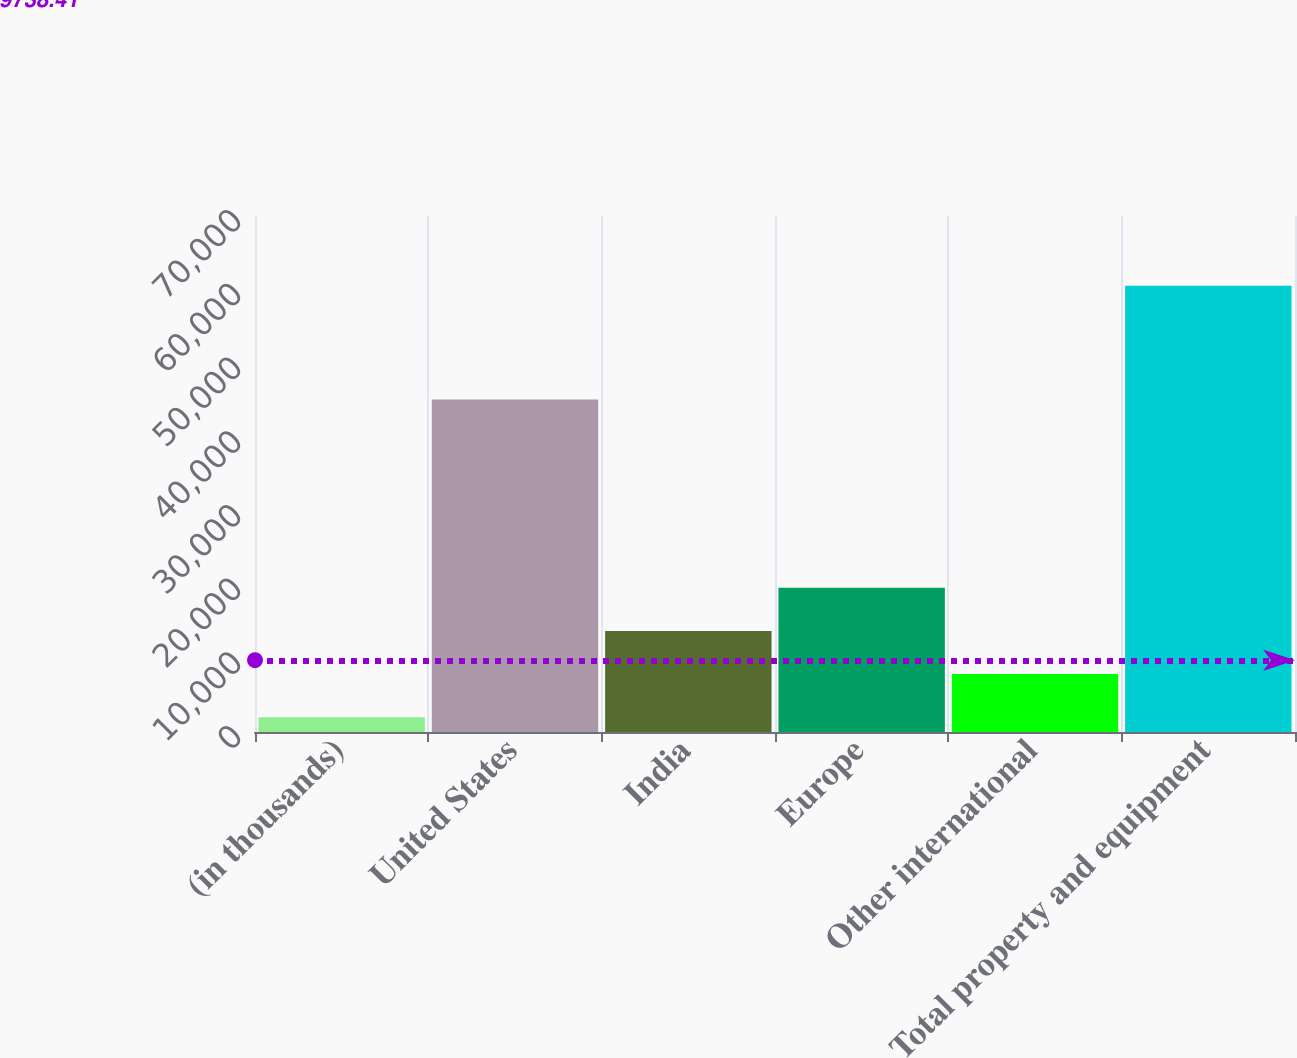Convert chart. <chart><loc_0><loc_0><loc_500><loc_500><bar_chart><fcel>(in thousands)<fcel>United States<fcel>India<fcel>Europe<fcel>Other international<fcel>Total property and equipment<nl><fcel>2013<fcel>45116<fcel>13718<fcel>19570.5<fcel>7865.5<fcel>60538<nl></chart> 